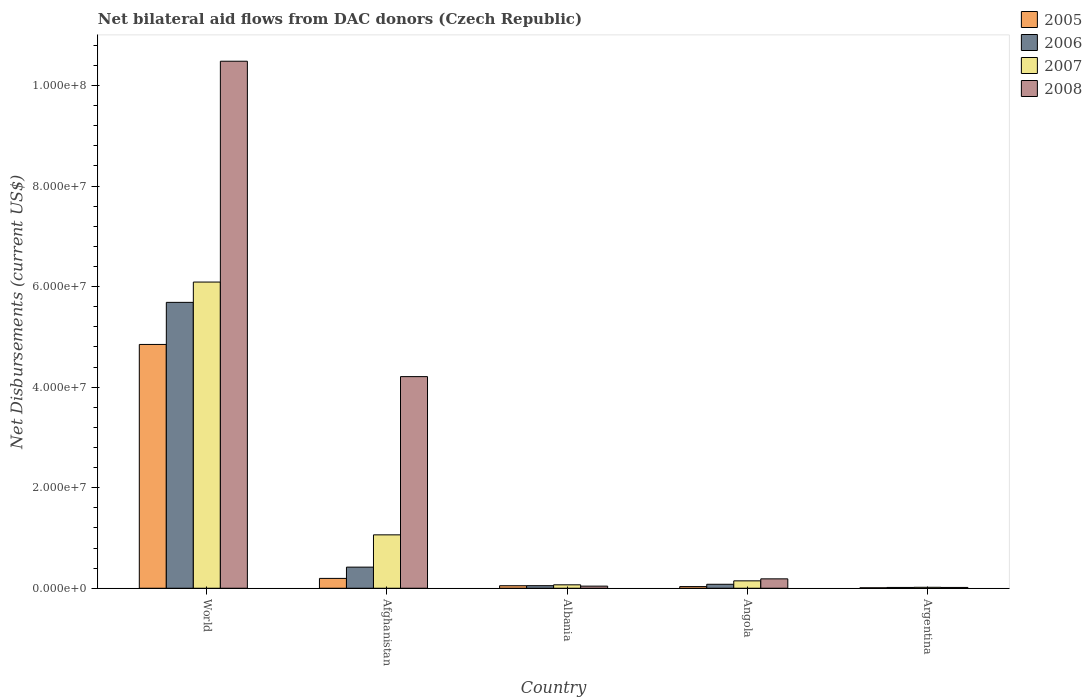How many different coloured bars are there?
Give a very brief answer. 4. How many groups of bars are there?
Offer a very short reply. 5. Are the number of bars on each tick of the X-axis equal?
Ensure brevity in your answer.  Yes. How many bars are there on the 1st tick from the right?
Keep it short and to the point. 4. What is the label of the 5th group of bars from the left?
Give a very brief answer. Argentina. In how many cases, is the number of bars for a given country not equal to the number of legend labels?
Give a very brief answer. 0. What is the net bilateral aid flows in 2007 in Afghanistan?
Offer a terse response. 1.06e+07. Across all countries, what is the maximum net bilateral aid flows in 2008?
Provide a short and direct response. 1.05e+08. Across all countries, what is the minimum net bilateral aid flows in 2006?
Your response must be concise. 1.60e+05. In which country was the net bilateral aid flows in 2007 minimum?
Your response must be concise. Argentina. What is the total net bilateral aid flows in 2005 in the graph?
Your response must be concise. 5.14e+07. What is the difference between the net bilateral aid flows in 2008 in Albania and that in World?
Your answer should be compact. -1.04e+08. What is the difference between the net bilateral aid flows in 2005 in World and the net bilateral aid flows in 2006 in Albania?
Your response must be concise. 4.80e+07. What is the average net bilateral aid flows in 2007 per country?
Offer a terse response. 1.48e+07. What is the difference between the net bilateral aid flows of/in 2005 and net bilateral aid flows of/in 2006 in World?
Your answer should be very brief. -8.37e+06. In how many countries, is the net bilateral aid flows in 2008 greater than 96000000 US$?
Make the answer very short. 1. What is the ratio of the net bilateral aid flows in 2005 in Afghanistan to that in Argentina?
Your answer should be very brief. 21.78. Is the net bilateral aid flows in 2005 in Afghanistan less than that in Albania?
Your answer should be very brief. No. Is the difference between the net bilateral aid flows in 2005 in Angola and World greater than the difference between the net bilateral aid flows in 2006 in Angola and World?
Your response must be concise. Yes. What is the difference between the highest and the second highest net bilateral aid flows in 2007?
Give a very brief answer. 5.94e+07. What is the difference between the highest and the lowest net bilateral aid flows in 2007?
Offer a very short reply. 6.07e+07. What does the 1st bar from the right in Angola represents?
Keep it short and to the point. 2008. How many bars are there?
Your answer should be very brief. 20. How many countries are there in the graph?
Offer a very short reply. 5. What is the difference between two consecutive major ticks on the Y-axis?
Your answer should be compact. 2.00e+07. Are the values on the major ticks of Y-axis written in scientific E-notation?
Ensure brevity in your answer.  Yes. Does the graph contain grids?
Provide a short and direct response. No. How are the legend labels stacked?
Offer a very short reply. Vertical. What is the title of the graph?
Offer a very short reply. Net bilateral aid flows from DAC donors (Czech Republic). Does "2002" appear as one of the legend labels in the graph?
Your response must be concise. No. What is the label or title of the Y-axis?
Keep it short and to the point. Net Disbursements (current US$). What is the Net Disbursements (current US$) of 2005 in World?
Your answer should be very brief. 4.85e+07. What is the Net Disbursements (current US$) in 2006 in World?
Provide a succinct answer. 5.69e+07. What is the Net Disbursements (current US$) in 2007 in World?
Ensure brevity in your answer.  6.09e+07. What is the Net Disbursements (current US$) of 2008 in World?
Your answer should be very brief. 1.05e+08. What is the Net Disbursements (current US$) of 2005 in Afghanistan?
Ensure brevity in your answer.  1.96e+06. What is the Net Disbursements (current US$) in 2006 in Afghanistan?
Provide a succinct answer. 4.20e+06. What is the Net Disbursements (current US$) of 2007 in Afghanistan?
Provide a succinct answer. 1.06e+07. What is the Net Disbursements (current US$) of 2008 in Afghanistan?
Your response must be concise. 4.21e+07. What is the Net Disbursements (current US$) of 2006 in Albania?
Offer a terse response. 5.10e+05. What is the Net Disbursements (current US$) in 2007 in Albania?
Give a very brief answer. 6.80e+05. What is the Net Disbursements (current US$) of 2008 in Albania?
Ensure brevity in your answer.  4.20e+05. What is the Net Disbursements (current US$) of 2006 in Angola?
Your response must be concise. 7.90e+05. What is the Net Disbursements (current US$) of 2007 in Angola?
Provide a short and direct response. 1.47e+06. What is the Net Disbursements (current US$) in 2008 in Angola?
Your answer should be very brief. 1.87e+06. What is the Net Disbursements (current US$) of 2005 in Argentina?
Offer a terse response. 9.00e+04. What is the Net Disbursements (current US$) of 2006 in Argentina?
Ensure brevity in your answer.  1.60e+05. Across all countries, what is the maximum Net Disbursements (current US$) in 2005?
Provide a succinct answer. 4.85e+07. Across all countries, what is the maximum Net Disbursements (current US$) in 2006?
Keep it short and to the point. 5.69e+07. Across all countries, what is the maximum Net Disbursements (current US$) in 2007?
Give a very brief answer. 6.09e+07. Across all countries, what is the maximum Net Disbursements (current US$) of 2008?
Your answer should be very brief. 1.05e+08. Across all countries, what is the minimum Net Disbursements (current US$) of 2006?
Your answer should be very brief. 1.60e+05. Across all countries, what is the minimum Net Disbursements (current US$) in 2007?
Provide a short and direct response. 1.90e+05. What is the total Net Disbursements (current US$) in 2005 in the graph?
Provide a short and direct response. 5.14e+07. What is the total Net Disbursements (current US$) of 2006 in the graph?
Your answer should be very brief. 6.25e+07. What is the total Net Disbursements (current US$) in 2007 in the graph?
Provide a succinct answer. 7.39e+07. What is the total Net Disbursements (current US$) of 2008 in the graph?
Offer a very short reply. 1.49e+08. What is the difference between the Net Disbursements (current US$) in 2005 in World and that in Afghanistan?
Make the answer very short. 4.65e+07. What is the difference between the Net Disbursements (current US$) of 2006 in World and that in Afghanistan?
Provide a short and direct response. 5.27e+07. What is the difference between the Net Disbursements (current US$) of 2007 in World and that in Afghanistan?
Make the answer very short. 5.03e+07. What is the difference between the Net Disbursements (current US$) of 2008 in World and that in Afghanistan?
Your answer should be very brief. 6.27e+07. What is the difference between the Net Disbursements (current US$) of 2005 in World and that in Albania?
Your answer should be very brief. 4.80e+07. What is the difference between the Net Disbursements (current US$) in 2006 in World and that in Albania?
Your answer should be compact. 5.64e+07. What is the difference between the Net Disbursements (current US$) of 2007 in World and that in Albania?
Ensure brevity in your answer.  6.02e+07. What is the difference between the Net Disbursements (current US$) of 2008 in World and that in Albania?
Keep it short and to the point. 1.04e+08. What is the difference between the Net Disbursements (current US$) in 2005 in World and that in Angola?
Keep it short and to the point. 4.82e+07. What is the difference between the Net Disbursements (current US$) of 2006 in World and that in Angola?
Your answer should be compact. 5.61e+07. What is the difference between the Net Disbursements (current US$) in 2007 in World and that in Angola?
Make the answer very short. 5.94e+07. What is the difference between the Net Disbursements (current US$) in 2008 in World and that in Angola?
Provide a short and direct response. 1.03e+08. What is the difference between the Net Disbursements (current US$) in 2005 in World and that in Argentina?
Keep it short and to the point. 4.84e+07. What is the difference between the Net Disbursements (current US$) of 2006 in World and that in Argentina?
Your answer should be compact. 5.67e+07. What is the difference between the Net Disbursements (current US$) of 2007 in World and that in Argentina?
Offer a very short reply. 6.07e+07. What is the difference between the Net Disbursements (current US$) of 2008 in World and that in Argentina?
Make the answer very short. 1.05e+08. What is the difference between the Net Disbursements (current US$) of 2005 in Afghanistan and that in Albania?
Offer a terse response. 1.46e+06. What is the difference between the Net Disbursements (current US$) of 2006 in Afghanistan and that in Albania?
Your answer should be very brief. 3.69e+06. What is the difference between the Net Disbursements (current US$) of 2007 in Afghanistan and that in Albania?
Keep it short and to the point. 9.94e+06. What is the difference between the Net Disbursements (current US$) in 2008 in Afghanistan and that in Albania?
Your answer should be compact. 4.17e+07. What is the difference between the Net Disbursements (current US$) in 2005 in Afghanistan and that in Angola?
Your response must be concise. 1.63e+06. What is the difference between the Net Disbursements (current US$) of 2006 in Afghanistan and that in Angola?
Your answer should be compact. 3.41e+06. What is the difference between the Net Disbursements (current US$) of 2007 in Afghanistan and that in Angola?
Your answer should be very brief. 9.15e+06. What is the difference between the Net Disbursements (current US$) in 2008 in Afghanistan and that in Angola?
Provide a short and direct response. 4.02e+07. What is the difference between the Net Disbursements (current US$) in 2005 in Afghanistan and that in Argentina?
Your answer should be very brief. 1.87e+06. What is the difference between the Net Disbursements (current US$) of 2006 in Afghanistan and that in Argentina?
Provide a succinct answer. 4.04e+06. What is the difference between the Net Disbursements (current US$) in 2007 in Afghanistan and that in Argentina?
Give a very brief answer. 1.04e+07. What is the difference between the Net Disbursements (current US$) of 2008 in Afghanistan and that in Argentina?
Your answer should be compact. 4.19e+07. What is the difference between the Net Disbursements (current US$) of 2005 in Albania and that in Angola?
Your response must be concise. 1.70e+05. What is the difference between the Net Disbursements (current US$) of 2006 in Albania and that in Angola?
Give a very brief answer. -2.80e+05. What is the difference between the Net Disbursements (current US$) in 2007 in Albania and that in Angola?
Keep it short and to the point. -7.90e+05. What is the difference between the Net Disbursements (current US$) of 2008 in Albania and that in Angola?
Your answer should be very brief. -1.45e+06. What is the difference between the Net Disbursements (current US$) of 2005 in Albania and that in Argentina?
Your answer should be compact. 4.10e+05. What is the difference between the Net Disbursements (current US$) of 2006 in Albania and that in Argentina?
Your response must be concise. 3.50e+05. What is the difference between the Net Disbursements (current US$) of 2008 in Albania and that in Argentina?
Provide a succinct answer. 2.60e+05. What is the difference between the Net Disbursements (current US$) of 2006 in Angola and that in Argentina?
Provide a succinct answer. 6.30e+05. What is the difference between the Net Disbursements (current US$) of 2007 in Angola and that in Argentina?
Offer a very short reply. 1.28e+06. What is the difference between the Net Disbursements (current US$) in 2008 in Angola and that in Argentina?
Offer a terse response. 1.71e+06. What is the difference between the Net Disbursements (current US$) in 2005 in World and the Net Disbursements (current US$) in 2006 in Afghanistan?
Offer a terse response. 4.43e+07. What is the difference between the Net Disbursements (current US$) of 2005 in World and the Net Disbursements (current US$) of 2007 in Afghanistan?
Provide a succinct answer. 3.79e+07. What is the difference between the Net Disbursements (current US$) of 2005 in World and the Net Disbursements (current US$) of 2008 in Afghanistan?
Give a very brief answer. 6.40e+06. What is the difference between the Net Disbursements (current US$) of 2006 in World and the Net Disbursements (current US$) of 2007 in Afghanistan?
Make the answer very short. 4.62e+07. What is the difference between the Net Disbursements (current US$) in 2006 in World and the Net Disbursements (current US$) in 2008 in Afghanistan?
Make the answer very short. 1.48e+07. What is the difference between the Net Disbursements (current US$) of 2007 in World and the Net Disbursements (current US$) of 2008 in Afghanistan?
Ensure brevity in your answer.  1.88e+07. What is the difference between the Net Disbursements (current US$) in 2005 in World and the Net Disbursements (current US$) in 2006 in Albania?
Your answer should be very brief. 4.80e+07. What is the difference between the Net Disbursements (current US$) of 2005 in World and the Net Disbursements (current US$) of 2007 in Albania?
Offer a very short reply. 4.78e+07. What is the difference between the Net Disbursements (current US$) in 2005 in World and the Net Disbursements (current US$) in 2008 in Albania?
Provide a succinct answer. 4.81e+07. What is the difference between the Net Disbursements (current US$) of 2006 in World and the Net Disbursements (current US$) of 2007 in Albania?
Make the answer very short. 5.62e+07. What is the difference between the Net Disbursements (current US$) in 2006 in World and the Net Disbursements (current US$) in 2008 in Albania?
Give a very brief answer. 5.64e+07. What is the difference between the Net Disbursements (current US$) in 2007 in World and the Net Disbursements (current US$) in 2008 in Albania?
Your answer should be compact. 6.05e+07. What is the difference between the Net Disbursements (current US$) of 2005 in World and the Net Disbursements (current US$) of 2006 in Angola?
Provide a short and direct response. 4.77e+07. What is the difference between the Net Disbursements (current US$) in 2005 in World and the Net Disbursements (current US$) in 2007 in Angola?
Keep it short and to the point. 4.70e+07. What is the difference between the Net Disbursements (current US$) in 2005 in World and the Net Disbursements (current US$) in 2008 in Angola?
Your answer should be very brief. 4.66e+07. What is the difference between the Net Disbursements (current US$) of 2006 in World and the Net Disbursements (current US$) of 2007 in Angola?
Offer a terse response. 5.54e+07. What is the difference between the Net Disbursements (current US$) of 2006 in World and the Net Disbursements (current US$) of 2008 in Angola?
Provide a short and direct response. 5.50e+07. What is the difference between the Net Disbursements (current US$) of 2007 in World and the Net Disbursements (current US$) of 2008 in Angola?
Your answer should be compact. 5.90e+07. What is the difference between the Net Disbursements (current US$) of 2005 in World and the Net Disbursements (current US$) of 2006 in Argentina?
Provide a short and direct response. 4.83e+07. What is the difference between the Net Disbursements (current US$) of 2005 in World and the Net Disbursements (current US$) of 2007 in Argentina?
Your answer should be very brief. 4.83e+07. What is the difference between the Net Disbursements (current US$) of 2005 in World and the Net Disbursements (current US$) of 2008 in Argentina?
Your response must be concise. 4.83e+07. What is the difference between the Net Disbursements (current US$) of 2006 in World and the Net Disbursements (current US$) of 2007 in Argentina?
Provide a succinct answer. 5.67e+07. What is the difference between the Net Disbursements (current US$) in 2006 in World and the Net Disbursements (current US$) in 2008 in Argentina?
Offer a very short reply. 5.67e+07. What is the difference between the Net Disbursements (current US$) of 2007 in World and the Net Disbursements (current US$) of 2008 in Argentina?
Offer a terse response. 6.08e+07. What is the difference between the Net Disbursements (current US$) in 2005 in Afghanistan and the Net Disbursements (current US$) in 2006 in Albania?
Ensure brevity in your answer.  1.45e+06. What is the difference between the Net Disbursements (current US$) in 2005 in Afghanistan and the Net Disbursements (current US$) in 2007 in Albania?
Ensure brevity in your answer.  1.28e+06. What is the difference between the Net Disbursements (current US$) of 2005 in Afghanistan and the Net Disbursements (current US$) of 2008 in Albania?
Offer a very short reply. 1.54e+06. What is the difference between the Net Disbursements (current US$) of 2006 in Afghanistan and the Net Disbursements (current US$) of 2007 in Albania?
Make the answer very short. 3.52e+06. What is the difference between the Net Disbursements (current US$) of 2006 in Afghanistan and the Net Disbursements (current US$) of 2008 in Albania?
Your answer should be very brief. 3.78e+06. What is the difference between the Net Disbursements (current US$) of 2007 in Afghanistan and the Net Disbursements (current US$) of 2008 in Albania?
Your answer should be very brief. 1.02e+07. What is the difference between the Net Disbursements (current US$) of 2005 in Afghanistan and the Net Disbursements (current US$) of 2006 in Angola?
Keep it short and to the point. 1.17e+06. What is the difference between the Net Disbursements (current US$) of 2005 in Afghanistan and the Net Disbursements (current US$) of 2007 in Angola?
Offer a terse response. 4.90e+05. What is the difference between the Net Disbursements (current US$) of 2005 in Afghanistan and the Net Disbursements (current US$) of 2008 in Angola?
Your answer should be compact. 9.00e+04. What is the difference between the Net Disbursements (current US$) of 2006 in Afghanistan and the Net Disbursements (current US$) of 2007 in Angola?
Keep it short and to the point. 2.73e+06. What is the difference between the Net Disbursements (current US$) in 2006 in Afghanistan and the Net Disbursements (current US$) in 2008 in Angola?
Keep it short and to the point. 2.33e+06. What is the difference between the Net Disbursements (current US$) in 2007 in Afghanistan and the Net Disbursements (current US$) in 2008 in Angola?
Your response must be concise. 8.75e+06. What is the difference between the Net Disbursements (current US$) of 2005 in Afghanistan and the Net Disbursements (current US$) of 2006 in Argentina?
Ensure brevity in your answer.  1.80e+06. What is the difference between the Net Disbursements (current US$) in 2005 in Afghanistan and the Net Disbursements (current US$) in 2007 in Argentina?
Offer a very short reply. 1.77e+06. What is the difference between the Net Disbursements (current US$) in 2005 in Afghanistan and the Net Disbursements (current US$) in 2008 in Argentina?
Make the answer very short. 1.80e+06. What is the difference between the Net Disbursements (current US$) in 2006 in Afghanistan and the Net Disbursements (current US$) in 2007 in Argentina?
Offer a terse response. 4.01e+06. What is the difference between the Net Disbursements (current US$) of 2006 in Afghanistan and the Net Disbursements (current US$) of 2008 in Argentina?
Ensure brevity in your answer.  4.04e+06. What is the difference between the Net Disbursements (current US$) of 2007 in Afghanistan and the Net Disbursements (current US$) of 2008 in Argentina?
Provide a short and direct response. 1.05e+07. What is the difference between the Net Disbursements (current US$) of 2005 in Albania and the Net Disbursements (current US$) of 2007 in Angola?
Your response must be concise. -9.70e+05. What is the difference between the Net Disbursements (current US$) of 2005 in Albania and the Net Disbursements (current US$) of 2008 in Angola?
Provide a short and direct response. -1.37e+06. What is the difference between the Net Disbursements (current US$) of 2006 in Albania and the Net Disbursements (current US$) of 2007 in Angola?
Offer a terse response. -9.60e+05. What is the difference between the Net Disbursements (current US$) of 2006 in Albania and the Net Disbursements (current US$) of 2008 in Angola?
Give a very brief answer. -1.36e+06. What is the difference between the Net Disbursements (current US$) in 2007 in Albania and the Net Disbursements (current US$) in 2008 in Angola?
Offer a terse response. -1.19e+06. What is the difference between the Net Disbursements (current US$) in 2005 in Albania and the Net Disbursements (current US$) in 2007 in Argentina?
Your answer should be compact. 3.10e+05. What is the difference between the Net Disbursements (current US$) in 2006 in Albania and the Net Disbursements (current US$) in 2008 in Argentina?
Ensure brevity in your answer.  3.50e+05. What is the difference between the Net Disbursements (current US$) of 2007 in Albania and the Net Disbursements (current US$) of 2008 in Argentina?
Ensure brevity in your answer.  5.20e+05. What is the difference between the Net Disbursements (current US$) in 2006 in Angola and the Net Disbursements (current US$) in 2007 in Argentina?
Keep it short and to the point. 6.00e+05. What is the difference between the Net Disbursements (current US$) in 2006 in Angola and the Net Disbursements (current US$) in 2008 in Argentina?
Your response must be concise. 6.30e+05. What is the difference between the Net Disbursements (current US$) of 2007 in Angola and the Net Disbursements (current US$) of 2008 in Argentina?
Keep it short and to the point. 1.31e+06. What is the average Net Disbursements (current US$) of 2005 per country?
Your answer should be very brief. 1.03e+07. What is the average Net Disbursements (current US$) of 2006 per country?
Ensure brevity in your answer.  1.25e+07. What is the average Net Disbursements (current US$) in 2007 per country?
Provide a succinct answer. 1.48e+07. What is the average Net Disbursements (current US$) in 2008 per country?
Provide a short and direct response. 2.99e+07. What is the difference between the Net Disbursements (current US$) in 2005 and Net Disbursements (current US$) in 2006 in World?
Ensure brevity in your answer.  -8.37e+06. What is the difference between the Net Disbursements (current US$) in 2005 and Net Disbursements (current US$) in 2007 in World?
Make the answer very short. -1.24e+07. What is the difference between the Net Disbursements (current US$) in 2005 and Net Disbursements (current US$) in 2008 in World?
Your response must be concise. -5.63e+07. What is the difference between the Net Disbursements (current US$) of 2006 and Net Disbursements (current US$) of 2007 in World?
Offer a very short reply. -4.04e+06. What is the difference between the Net Disbursements (current US$) of 2006 and Net Disbursements (current US$) of 2008 in World?
Provide a succinct answer. -4.80e+07. What is the difference between the Net Disbursements (current US$) in 2007 and Net Disbursements (current US$) in 2008 in World?
Keep it short and to the point. -4.39e+07. What is the difference between the Net Disbursements (current US$) in 2005 and Net Disbursements (current US$) in 2006 in Afghanistan?
Your response must be concise. -2.24e+06. What is the difference between the Net Disbursements (current US$) in 2005 and Net Disbursements (current US$) in 2007 in Afghanistan?
Make the answer very short. -8.66e+06. What is the difference between the Net Disbursements (current US$) of 2005 and Net Disbursements (current US$) of 2008 in Afghanistan?
Your answer should be compact. -4.01e+07. What is the difference between the Net Disbursements (current US$) in 2006 and Net Disbursements (current US$) in 2007 in Afghanistan?
Your answer should be compact. -6.42e+06. What is the difference between the Net Disbursements (current US$) of 2006 and Net Disbursements (current US$) of 2008 in Afghanistan?
Offer a terse response. -3.79e+07. What is the difference between the Net Disbursements (current US$) in 2007 and Net Disbursements (current US$) in 2008 in Afghanistan?
Ensure brevity in your answer.  -3.15e+07. What is the difference between the Net Disbursements (current US$) of 2005 and Net Disbursements (current US$) of 2007 in Albania?
Give a very brief answer. -1.80e+05. What is the difference between the Net Disbursements (current US$) of 2005 and Net Disbursements (current US$) of 2008 in Albania?
Provide a short and direct response. 8.00e+04. What is the difference between the Net Disbursements (current US$) in 2006 and Net Disbursements (current US$) in 2008 in Albania?
Give a very brief answer. 9.00e+04. What is the difference between the Net Disbursements (current US$) in 2007 and Net Disbursements (current US$) in 2008 in Albania?
Your response must be concise. 2.60e+05. What is the difference between the Net Disbursements (current US$) in 2005 and Net Disbursements (current US$) in 2006 in Angola?
Provide a short and direct response. -4.60e+05. What is the difference between the Net Disbursements (current US$) in 2005 and Net Disbursements (current US$) in 2007 in Angola?
Your answer should be compact. -1.14e+06. What is the difference between the Net Disbursements (current US$) of 2005 and Net Disbursements (current US$) of 2008 in Angola?
Keep it short and to the point. -1.54e+06. What is the difference between the Net Disbursements (current US$) in 2006 and Net Disbursements (current US$) in 2007 in Angola?
Offer a terse response. -6.80e+05. What is the difference between the Net Disbursements (current US$) in 2006 and Net Disbursements (current US$) in 2008 in Angola?
Keep it short and to the point. -1.08e+06. What is the difference between the Net Disbursements (current US$) of 2007 and Net Disbursements (current US$) of 2008 in Angola?
Offer a very short reply. -4.00e+05. What is the difference between the Net Disbursements (current US$) of 2005 and Net Disbursements (current US$) of 2006 in Argentina?
Give a very brief answer. -7.00e+04. What is the difference between the Net Disbursements (current US$) of 2005 and Net Disbursements (current US$) of 2007 in Argentina?
Your response must be concise. -1.00e+05. What is the difference between the Net Disbursements (current US$) in 2005 and Net Disbursements (current US$) in 2008 in Argentina?
Your response must be concise. -7.00e+04. What is the difference between the Net Disbursements (current US$) of 2006 and Net Disbursements (current US$) of 2007 in Argentina?
Make the answer very short. -3.00e+04. What is the difference between the Net Disbursements (current US$) of 2006 and Net Disbursements (current US$) of 2008 in Argentina?
Offer a very short reply. 0. What is the ratio of the Net Disbursements (current US$) of 2005 in World to that in Afghanistan?
Your answer should be compact. 24.74. What is the ratio of the Net Disbursements (current US$) in 2006 in World to that in Afghanistan?
Provide a succinct answer. 13.54. What is the ratio of the Net Disbursements (current US$) of 2007 in World to that in Afghanistan?
Your answer should be compact. 5.74. What is the ratio of the Net Disbursements (current US$) in 2008 in World to that in Afghanistan?
Your answer should be compact. 2.49. What is the ratio of the Net Disbursements (current US$) in 2005 in World to that in Albania?
Provide a succinct answer. 97. What is the ratio of the Net Disbursements (current US$) of 2006 in World to that in Albania?
Offer a terse response. 111.51. What is the ratio of the Net Disbursements (current US$) of 2007 in World to that in Albania?
Provide a succinct answer. 89.57. What is the ratio of the Net Disbursements (current US$) of 2008 in World to that in Albania?
Ensure brevity in your answer.  249.62. What is the ratio of the Net Disbursements (current US$) of 2005 in World to that in Angola?
Your response must be concise. 146.97. What is the ratio of the Net Disbursements (current US$) in 2006 in World to that in Angola?
Ensure brevity in your answer.  71.99. What is the ratio of the Net Disbursements (current US$) of 2007 in World to that in Angola?
Ensure brevity in your answer.  41.44. What is the ratio of the Net Disbursements (current US$) of 2008 in World to that in Angola?
Provide a succinct answer. 56.06. What is the ratio of the Net Disbursements (current US$) in 2005 in World to that in Argentina?
Provide a succinct answer. 538.89. What is the ratio of the Net Disbursements (current US$) in 2006 in World to that in Argentina?
Make the answer very short. 355.44. What is the ratio of the Net Disbursements (current US$) in 2007 in World to that in Argentina?
Offer a very short reply. 320.58. What is the ratio of the Net Disbursements (current US$) in 2008 in World to that in Argentina?
Keep it short and to the point. 655.25. What is the ratio of the Net Disbursements (current US$) in 2005 in Afghanistan to that in Albania?
Your response must be concise. 3.92. What is the ratio of the Net Disbursements (current US$) in 2006 in Afghanistan to that in Albania?
Ensure brevity in your answer.  8.24. What is the ratio of the Net Disbursements (current US$) of 2007 in Afghanistan to that in Albania?
Ensure brevity in your answer.  15.62. What is the ratio of the Net Disbursements (current US$) in 2008 in Afghanistan to that in Albania?
Offer a very short reply. 100.24. What is the ratio of the Net Disbursements (current US$) of 2005 in Afghanistan to that in Angola?
Give a very brief answer. 5.94. What is the ratio of the Net Disbursements (current US$) of 2006 in Afghanistan to that in Angola?
Ensure brevity in your answer.  5.32. What is the ratio of the Net Disbursements (current US$) of 2007 in Afghanistan to that in Angola?
Your answer should be compact. 7.22. What is the ratio of the Net Disbursements (current US$) of 2008 in Afghanistan to that in Angola?
Your answer should be very brief. 22.51. What is the ratio of the Net Disbursements (current US$) in 2005 in Afghanistan to that in Argentina?
Offer a terse response. 21.78. What is the ratio of the Net Disbursements (current US$) in 2006 in Afghanistan to that in Argentina?
Keep it short and to the point. 26.25. What is the ratio of the Net Disbursements (current US$) of 2007 in Afghanistan to that in Argentina?
Provide a succinct answer. 55.89. What is the ratio of the Net Disbursements (current US$) in 2008 in Afghanistan to that in Argentina?
Give a very brief answer. 263.12. What is the ratio of the Net Disbursements (current US$) in 2005 in Albania to that in Angola?
Offer a terse response. 1.52. What is the ratio of the Net Disbursements (current US$) in 2006 in Albania to that in Angola?
Provide a short and direct response. 0.65. What is the ratio of the Net Disbursements (current US$) in 2007 in Albania to that in Angola?
Provide a short and direct response. 0.46. What is the ratio of the Net Disbursements (current US$) of 2008 in Albania to that in Angola?
Your answer should be compact. 0.22. What is the ratio of the Net Disbursements (current US$) in 2005 in Albania to that in Argentina?
Ensure brevity in your answer.  5.56. What is the ratio of the Net Disbursements (current US$) in 2006 in Albania to that in Argentina?
Offer a very short reply. 3.19. What is the ratio of the Net Disbursements (current US$) of 2007 in Albania to that in Argentina?
Ensure brevity in your answer.  3.58. What is the ratio of the Net Disbursements (current US$) in 2008 in Albania to that in Argentina?
Give a very brief answer. 2.62. What is the ratio of the Net Disbursements (current US$) of 2005 in Angola to that in Argentina?
Provide a succinct answer. 3.67. What is the ratio of the Net Disbursements (current US$) in 2006 in Angola to that in Argentina?
Give a very brief answer. 4.94. What is the ratio of the Net Disbursements (current US$) in 2007 in Angola to that in Argentina?
Offer a very short reply. 7.74. What is the ratio of the Net Disbursements (current US$) in 2008 in Angola to that in Argentina?
Ensure brevity in your answer.  11.69. What is the difference between the highest and the second highest Net Disbursements (current US$) in 2005?
Keep it short and to the point. 4.65e+07. What is the difference between the highest and the second highest Net Disbursements (current US$) in 2006?
Keep it short and to the point. 5.27e+07. What is the difference between the highest and the second highest Net Disbursements (current US$) of 2007?
Ensure brevity in your answer.  5.03e+07. What is the difference between the highest and the second highest Net Disbursements (current US$) of 2008?
Keep it short and to the point. 6.27e+07. What is the difference between the highest and the lowest Net Disbursements (current US$) in 2005?
Make the answer very short. 4.84e+07. What is the difference between the highest and the lowest Net Disbursements (current US$) in 2006?
Your response must be concise. 5.67e+07. What is the difference between the highest and the lowest Net Disbursements (current US$) in 2007?
Your answer should be compact. 6.07e+07. What is the difference between the highest and the lowest Net Disbursements (current US$) in 2008?
Offer a terse response. 1.05e+08. 